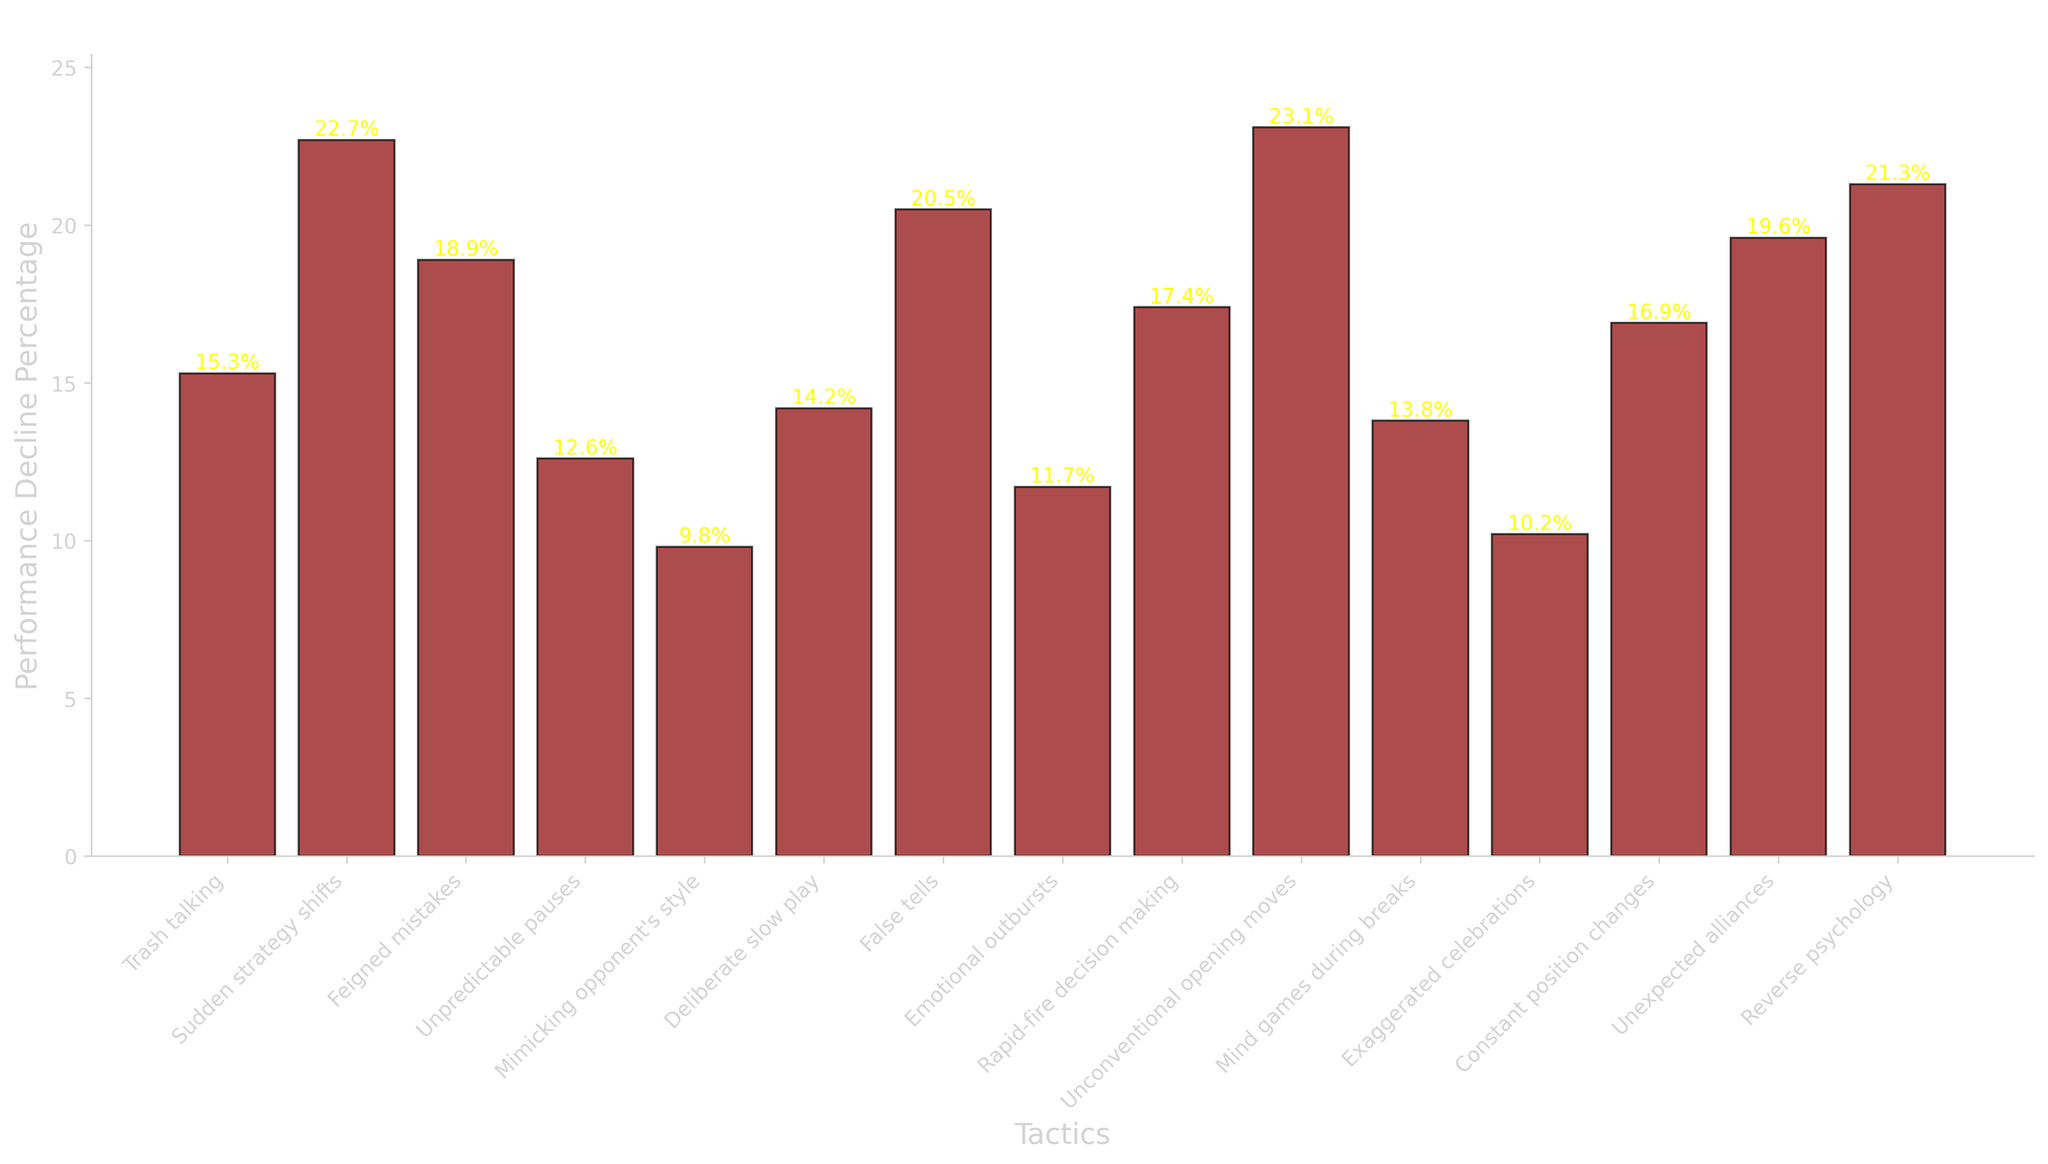Which tactic showed the highest performance decline percentage in opponents? Look at the heights of all the bars and find the tallest one. The tactic with the tallest bar represents the highest performance decline percentage, which is "Unconventional opening moves" at 23.1%.
Answer: Unconventional opening moves How much greater is the performance decline percentage of "Sudden strategy shifts" compared to "Mimicking opponent's style"? Identify the performance decline percentages for both tactics: "Sudden strategy shifts" is 22.7% and "Mimicking opponent's style" is 9.8%. Subtract the two: 22.7% - 9.8% = 12.9%.
Answer: 12.9% Which two tactics have performance decline percentages closest to 20%? Locate the tactics with percentages around 20%. "False tells" has 20.5% and "Reverse psychology" has 21.3%, both close to 20%.
Answer: False tells, Reverse psychology What is the average performance decline percentage across all tactics? Sum up all the percentages and divide by the number of tactics. The total sum is: 15.3 + 22.7 + 18.9 + 12.6 + 9.8 + 14.2 + 20.5 + 11.7 + 17.4 + 23.1 + 13.8 + 10.2 + 16.9 + 19.6 + 21.3 = 238.0. There are 15 tactics, so the average is 238.0 / 15 = 15.87%.
Answer: 15.87% What is the median performance decline percentage for all tactics? List all performance decline percentages in ascending order: 9.8, 10.2, 11.7, 12.6, 13.8, 14.2, 15.3, 16.9, 17.4, 18.9, 19.6, 20.5, 21.3, 22.7, 23.1. The middle value in this ordered list is 16.9%, as there are 15 data points.
Answer: 16.9% Which tactics have a performance decline percentage less than the average decline (15.87%)? Compare each tactic's performance decline percentage with the average value of 15.87%. The qualifying tactics are: "Mimicking opponent's style" (9.8%), "Unpredictable pauses" (12.6%), "Emotional outbursts" (11.7%), "Exaggerated celebrations" (10.2%), and "Mind games during breaks" (13.8%).
Answer: Mimicking opponent's style, Unpredictable pauses, Emotional outbursts, Exaggerated celebrations, Mind games during breaks How much more effective is "False tells" than "Trash talking" at causing performance decline? Identify the performance decline percentages: "False tells" is 20.5% and "Trash talking" is 15.3%. Calculate the difference: 20.5% - 15.3% = 5.2%.
Answer: 5.2% Which tactic managed to reduce opponent performance by less than 10 percentage points? Look through the bars for performance decline percentages less than 10%. "Mimicking opponent's style" has 9.8%, which is less than 10%.
Answer: Mimicking opponent's style 